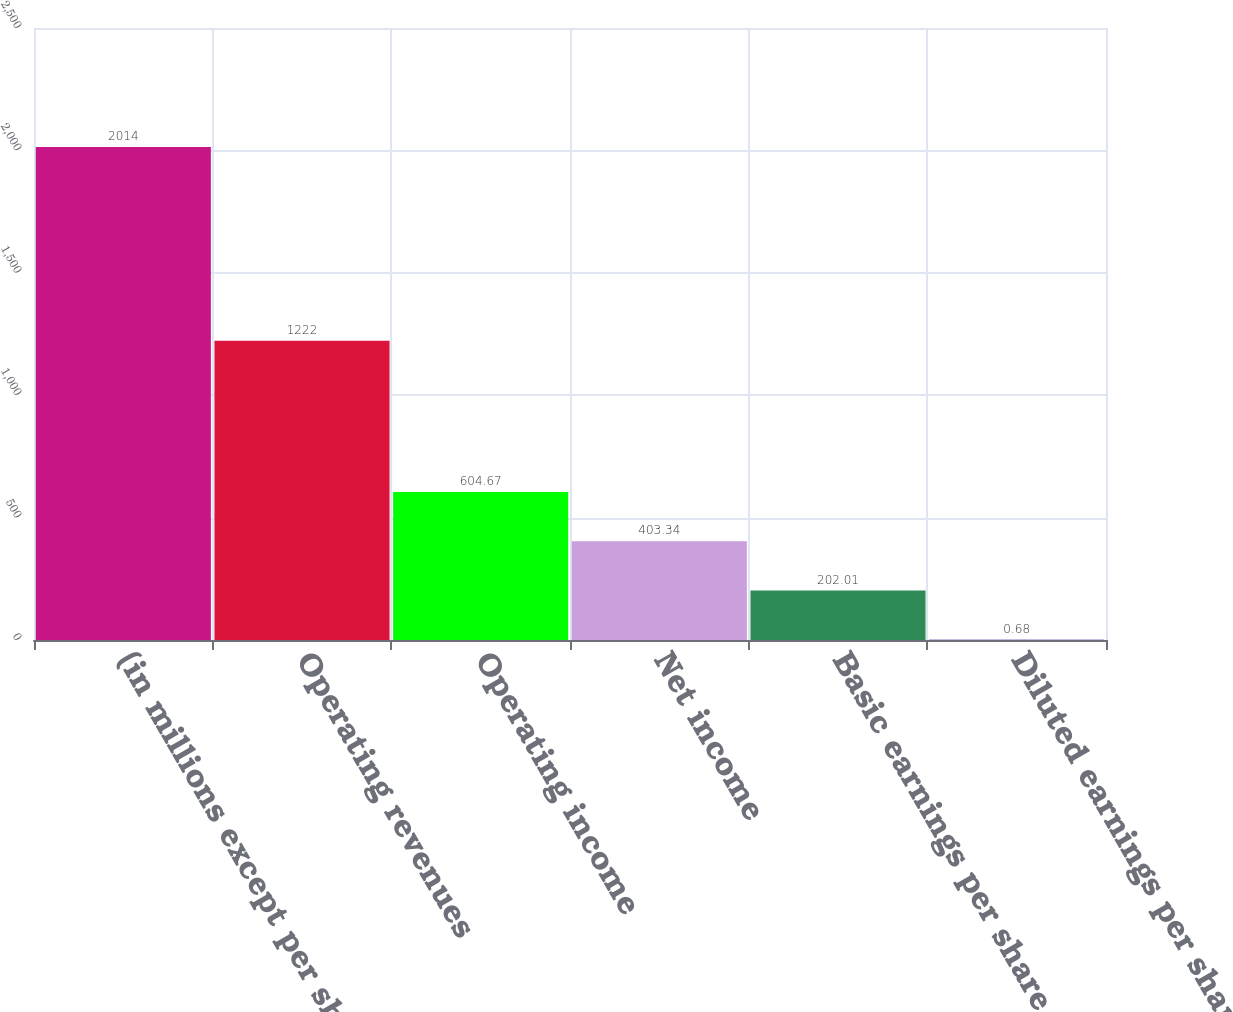Convert chart to OTSL. <chart><loc_0><loc_0><loc_500><loc_500><bar_chart><fcel>(in millions except per share)<fcel>Operating revenues<fcel>Operating income<fcel>Net income<fcel>Basic earnings per share (a)<fcel>Diluted earnings per share (a)<nl><fcel>2014<fcel>1222<fcel>604.67<fcel>403.34<fcel>202.01<fcel>0.68<nl></chart> 